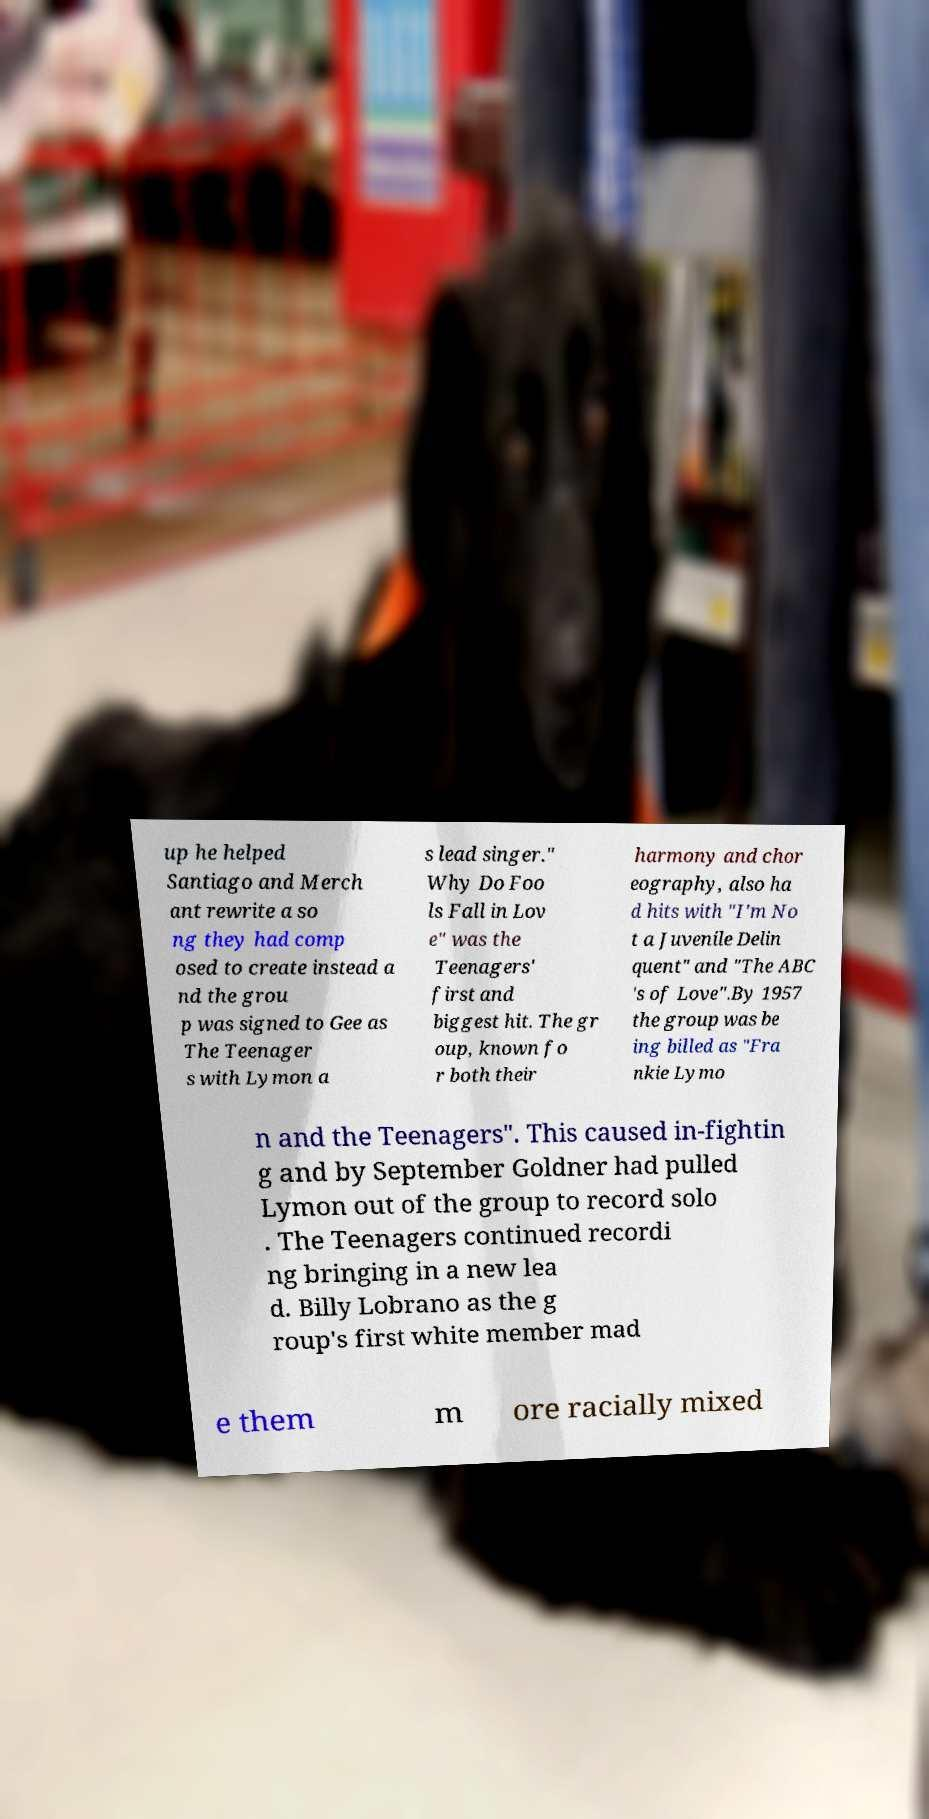For documentation purposes, I need the text within this image transcribed. Could you provide that? up he helped Santiago and Merch ant rewrite a so ng they had comp osed to create instead a nd the grou p was signed to Gee as The Teenager s with Lymon a s lead singer." Why Do Foo ls Fall in Lov e" was the Teenagers' first and biggest hit. The gr oup, known fo r both their harmony and chor eography, also ha d hits with "I'm No t a Juvenile Delin quent" and "The ABC 's of Love".By 1957 the group was be ing billed as "Fra nkie Lymo n and the Teenagers". This caused in-fightin g and by September Goldner had pulled Lymon out of the group to record solo . The Teenagers continued recordi ng bringing in a new lea d. Billy Lobrano as the g roup's first white member mad e them m ore racially mixed 